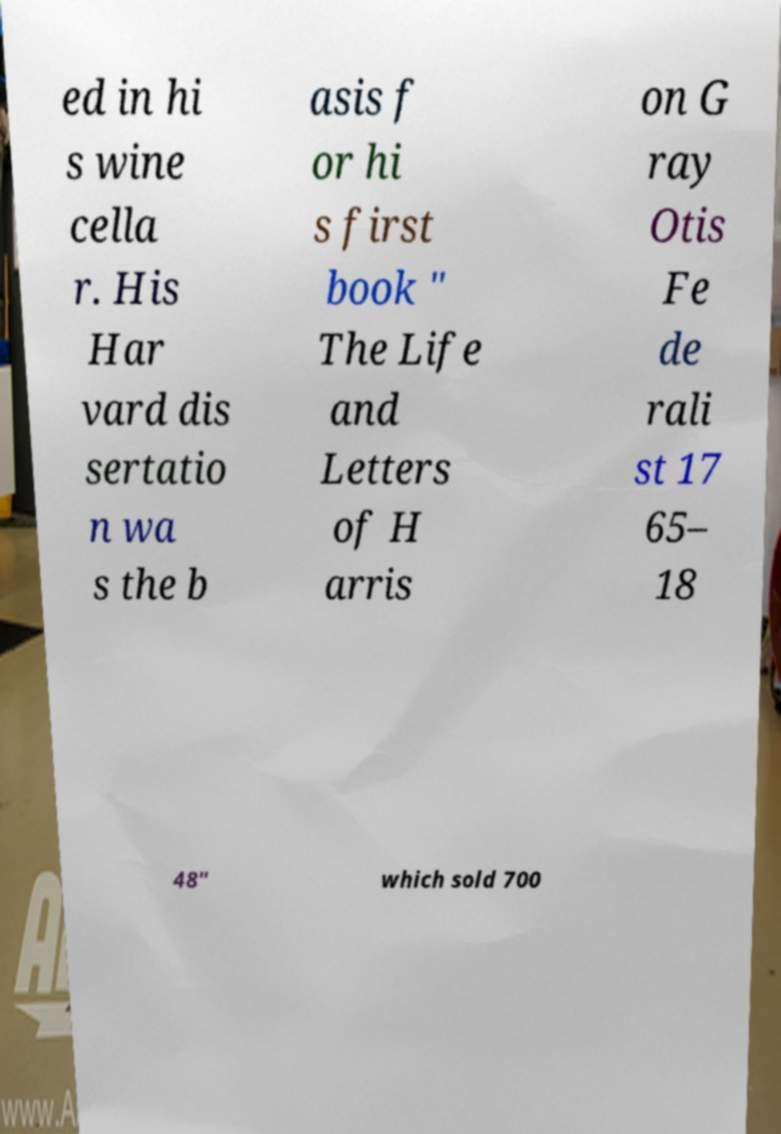There's text embedded in this image that I need extracted. Can you transcribe it verbatim? ed in hi s wine cella r. His Har vard dis sertatio n wa s the b asis f or hi s first book " The Life and Letters of H arris on G ray Otis Fe de rali st 17 65– 18 48" which sold 700 